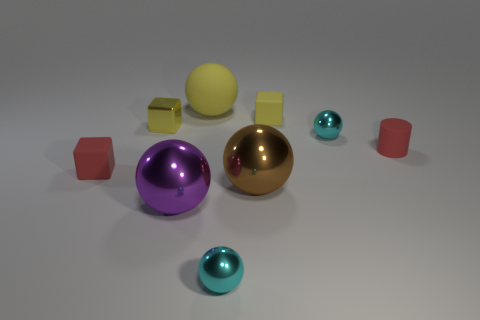Subtract all large brown balls. How many balls are left? 4 Subtract all green cylinders. How many cyan balls are left? 2 Subtract all red blocks. How many blocks are left? 2 Subtract all cubes. How many objects are left? 6 Add 1 cubes. How many objects exist? 10 Subtract 2 blocks. How many blocks are left? 1 Subtract 0 purple cylinders. How many objects are left? 9 Subtract all cyan blocks. Subtract all brown spheres. How many blocks are left? 3 Subtract all tiny balls. Subtract all matte things. How many objects are left? 3 Add 6 yellow objects. How many yellow objects are left? 9 